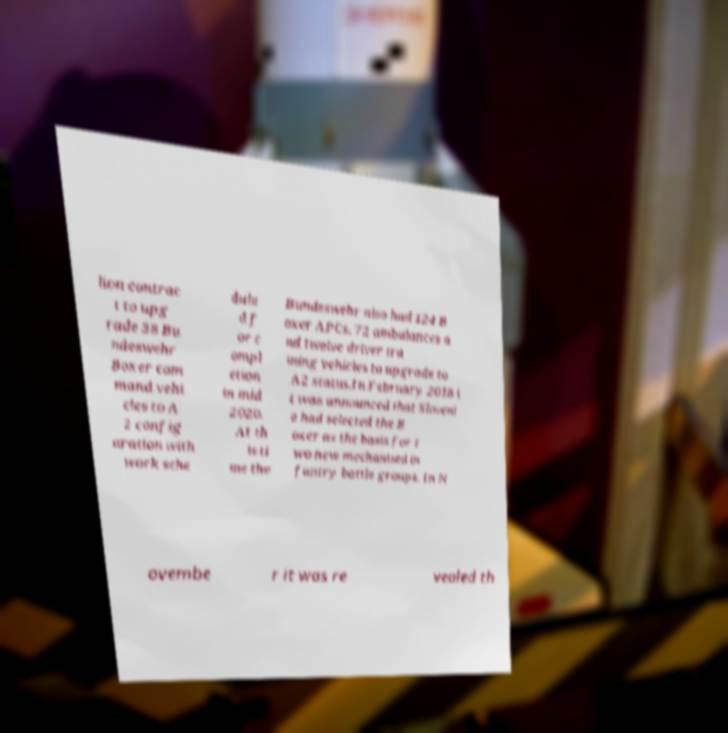Please identify and transcribe the text found in this image. lion contrac t to upg rade 38 Bu ndeswehr Boxer com mand vehi cles to A 2 config uration with work sche dule d f or c ompl etion in mid 2020. At th is ti me the Bundeswehr also had 124 B oxer APCs, 72 ambulances a nd twelve driver tra ining vehicles to upgrade to A2 status.In February 2018 i t was announced that Sloveni a had selected the B oxer as the basis for t wo new mechanised in fantry battle groups. In N ovembe r it was re vealed th 